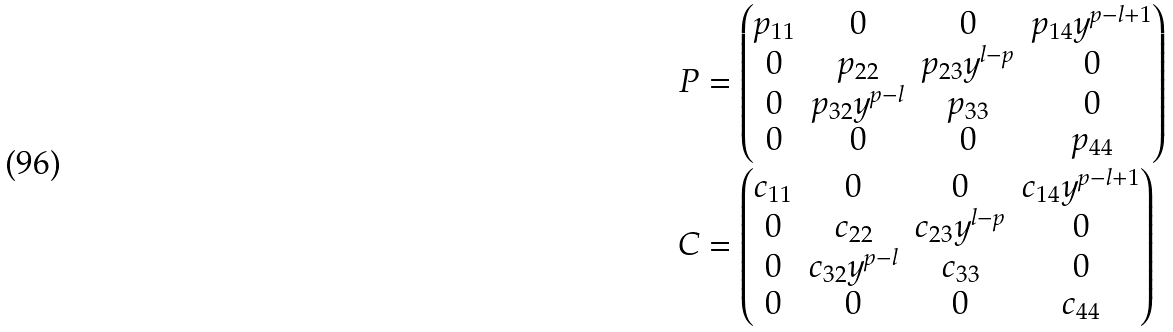<formula> <loc_0><loc_0><loc_500><loc_500>P & = \begin{pmatrix} p _ { 1 1 } & 0 & 0 & p _ { 1 4 } y ^ { p - l + 1 } \\ 0 & p _ { 2 2 } & p _ { 2 3 } y ^ { l - p } & 0 \\ 0 & p _ { 3 2 } y ^ { p - l } & p _ { 3 3 } & 0 \\ 0 & 0 & 0 & p _ { 4 4 } \end{pmatrix} \\ C & = \begin{pmatrix} c _ { 1 1 } & 0 & 0 & c _ { 1 4 } y ^ { p - l + 1 } \\ 0 & c _ { 2 2 } & c _ { 2 3 } y ^ { l - p } & 0 \\ 0 & c _ { 3 2 } y ^ { p - l } & c _ { 3 3 } & 0 \\ 0 & 0 & 0 & c _ { 4 4 } \end{pmatrix}</formula> 